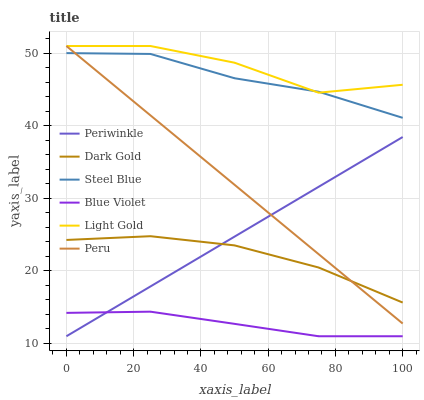Does Blue Violet have the minimum area under the curve?
Answer yes or no. Yes. Does Light Gold have the maximum area under the curve?
Answer yes or no. Yes. Does Steel Blue have the minimum area under the curve?
Answer yes or no. No. Does Steel Blue have the maximum area under the curve?
Answer yes or no. No. Is Periwinkle the smoothest?
Answer yes or no. Yes. Is Light Gold the roughest?
Answer yes or no. Yes. Is Steel Blue the smoothest?
Answer yes or no. No. Is Steel Blue the roughest?
Answer yes or no. No. Does Steel Blue have the lowest value?
Answer yes or no. No. Does Steel Blue have the highest value?
Answer yes or no. No. Is Blue Violet less than Steel Blue?
Answer yes or no. Yes. Is Steel Blue greater than Dark Gold?
Answer yes or no. Yes. Does Blue Violet intersect Steel Blue?
Answer yes or no. No. 